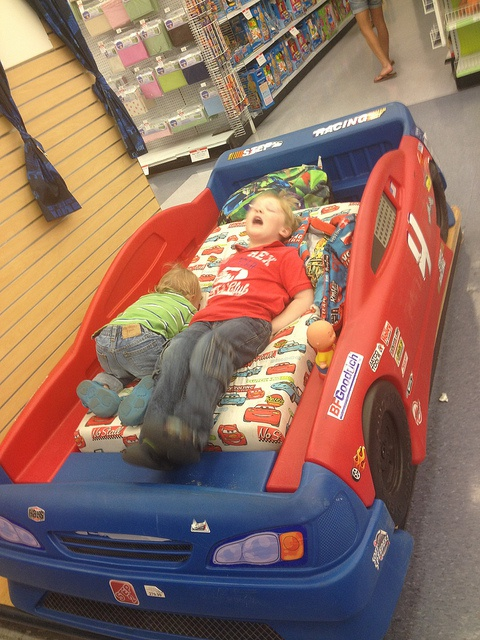Describe the objects in this image and their specific colors. I can see people in khaki, gray, salmon, tan, and black tones, bed in khaki, lightyellow, tan, salmon, and gray tones, people in khaki, gray, olive, and darkgray tones, and people in khaki, maroon, gray, and brown tones in this image. 